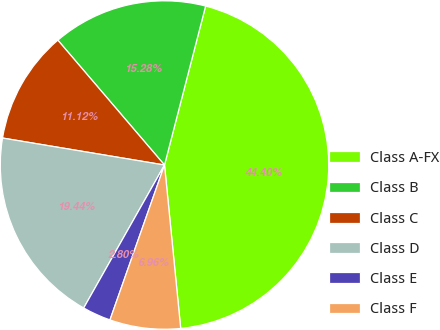<chart> <loc_0><loc_0><loc_500><loc_500><pie_chart><fcel>Class A-FX<fcel>Class B<fcel>Class C<fcel>Class D<fcel>Class E<fcel>Class F<nl><fcel>44.4%<fcel>15.28%<fcel>11.12%<fcel>19.44%<fcel>2.8%<fcel>6.96%<nl></chart> 